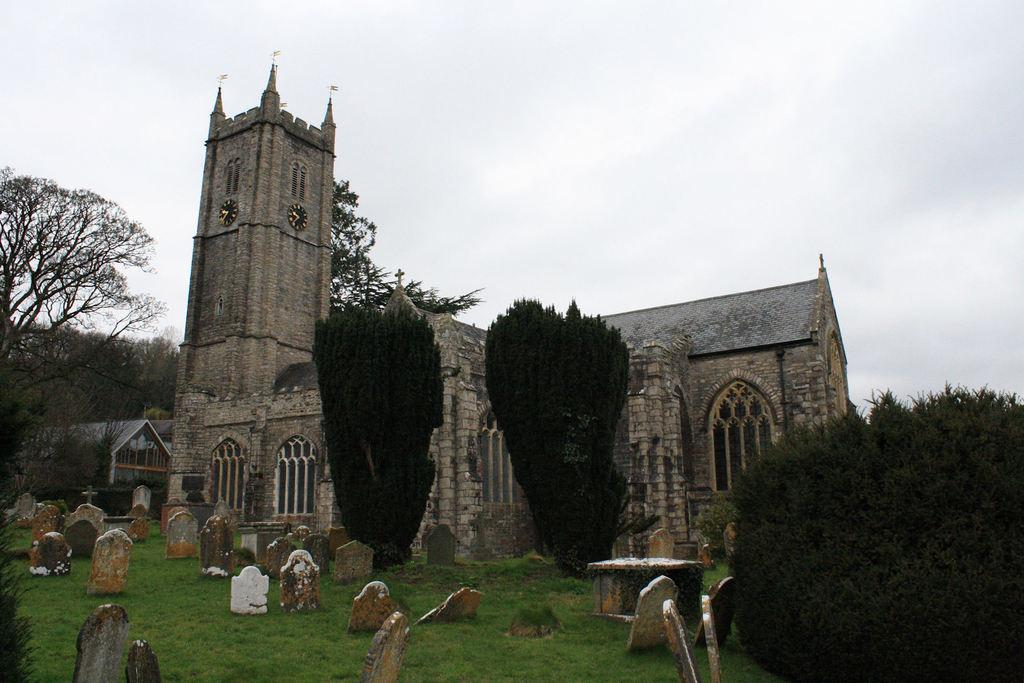What is the main structure visible in the image? There is a castle in the image. Where is the castle located in relation to the other elements in the image? The castle is in the back of the image. What type of vegetation is present in front of the castle? There are trees in front of the castle in the image. What other notable feature can be seen in the image? There is a cemetery in the image. What type of hope can be seen growing on the trees in the image? There is no mention of hope or any plant growing on the trees in the image. Can you tell me how many tails are visible on the castle in the image? There are no tails present on the castle in the image. 